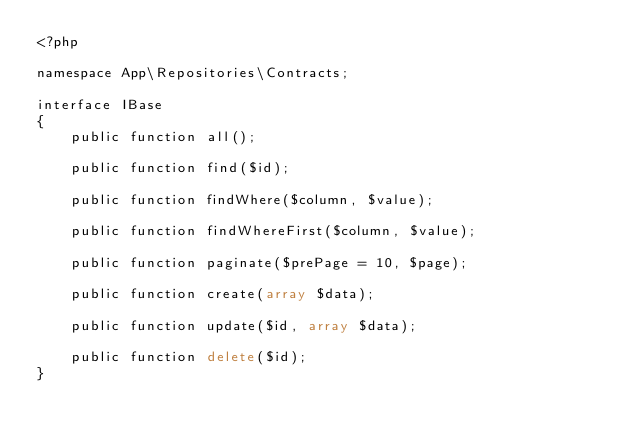Convert code to text. <code><loc_0><loc_0><loc_500><loc_500><_PHP_><?php

namespace App\Repositories\Contracts;

interface IBase
{
    public function all();

    public function find($id);

    public function findWhere($column, $value);

    public function findWhereFirst($column, $value);

    public function paginate($prePage = 10, $page);

    public function create(array $data);

    public function update($id, array $data);

    public function delete($id);
}
</code> 